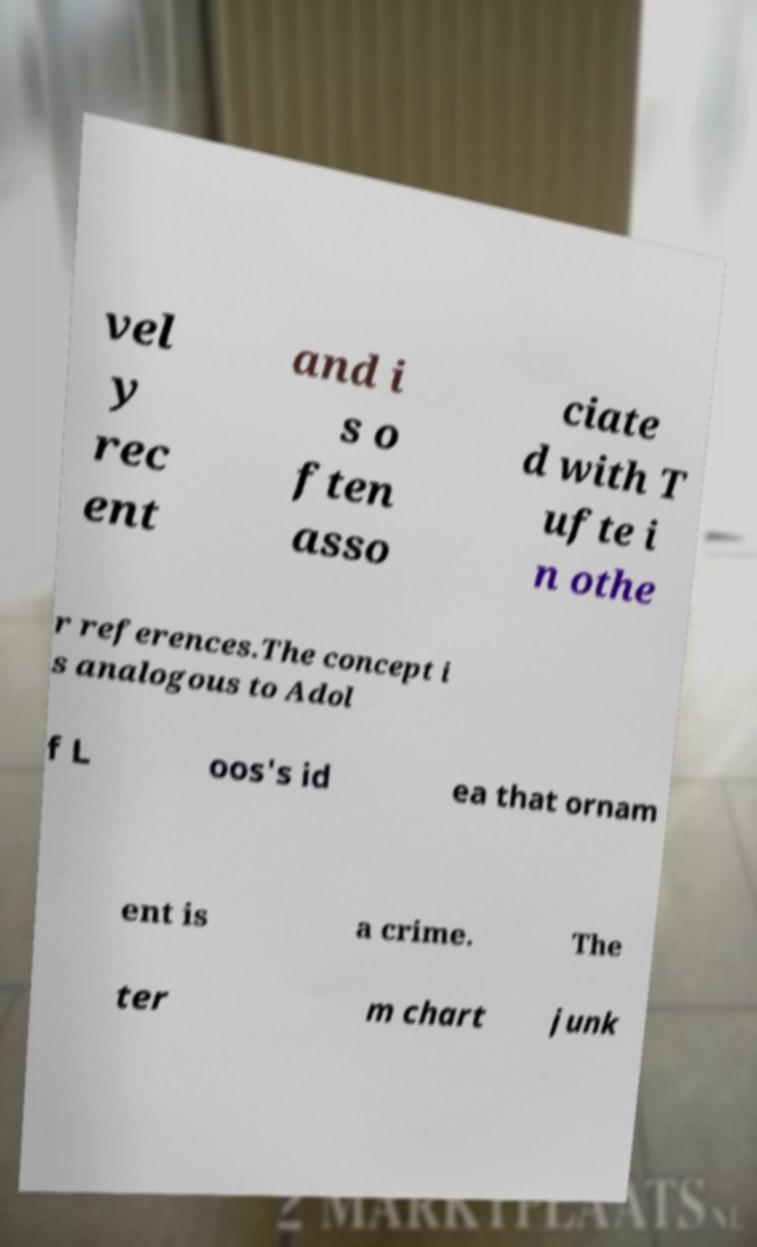Can you accurately transcribe the text from the provided image for me? vel y rec ent and i s o ften asso ciate d with T ufte i n othe r references.The concept i s analogous to Adol f L oos's id ea that ornam ent is a crime. The ter m chart junk 